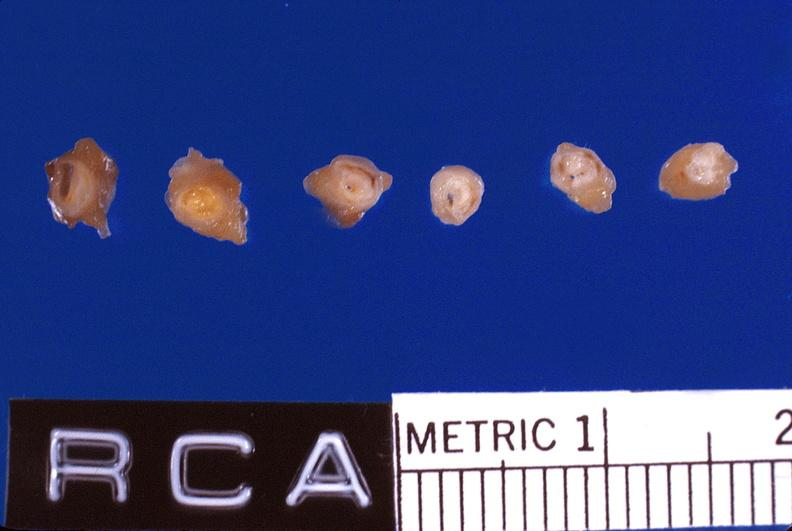s vasculature present?
Answer the question using a single word or phrase. Yes 